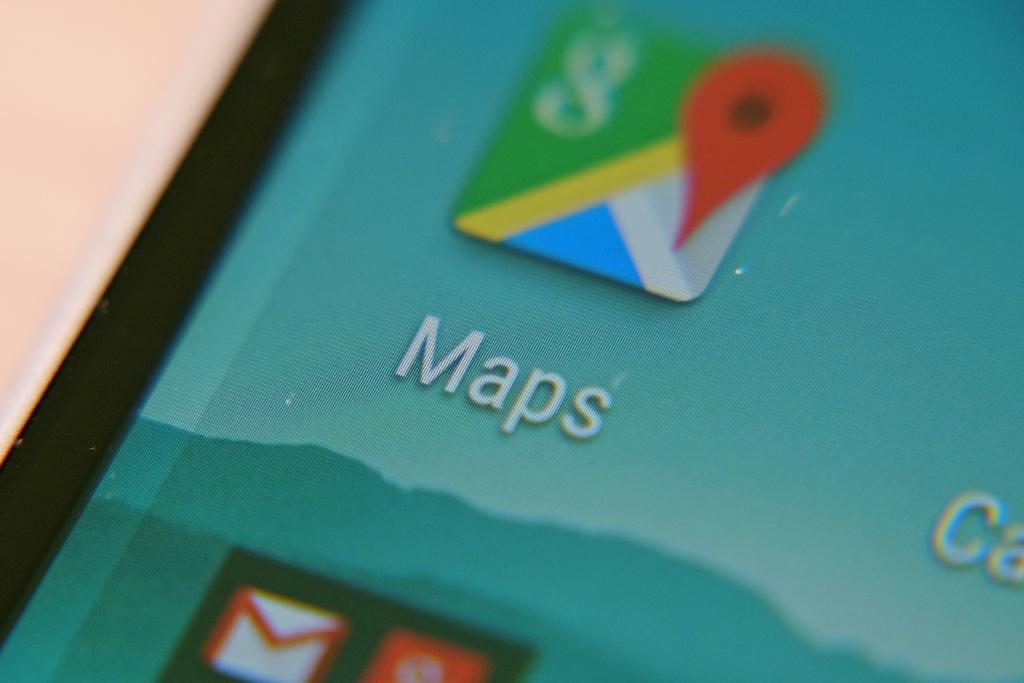<image>
Write a terse but informative summary of the picture. A picture of a mobile device screen with Google Maps icon. 